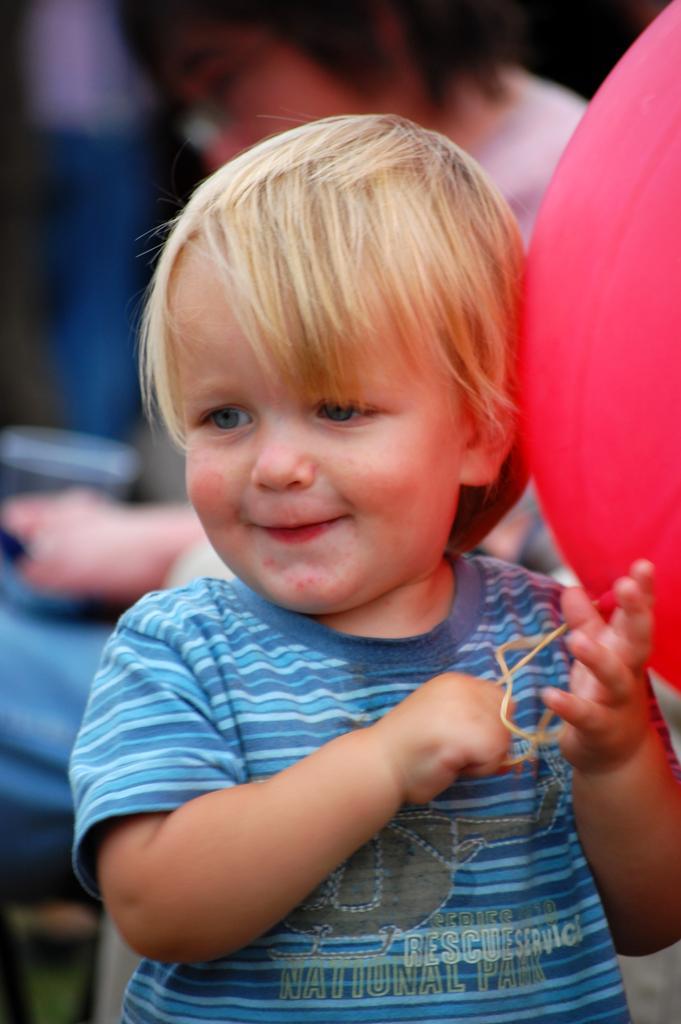Please provide a concise description of this image. This image consists of a holding a balloon. The balloon is in red color. In the background, there is a person sitting. The boy is wearing a blue T-shirt. 